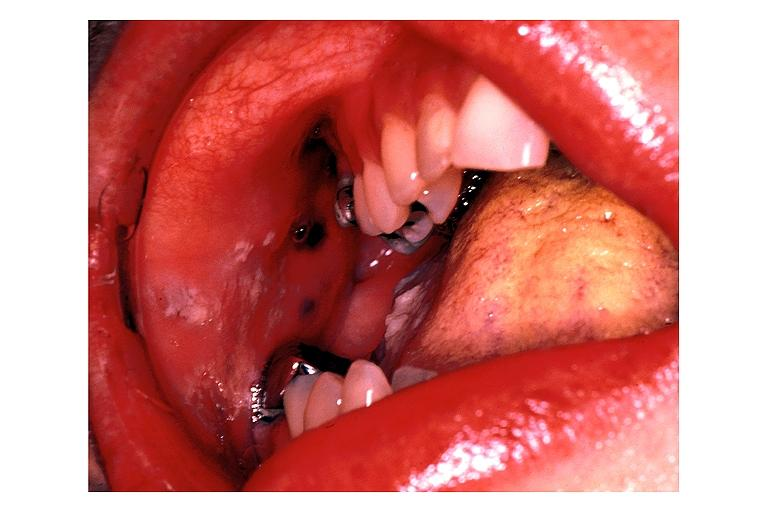does lip show peutz geghers syndrome?
Answer the question using a single word or phrase. No 